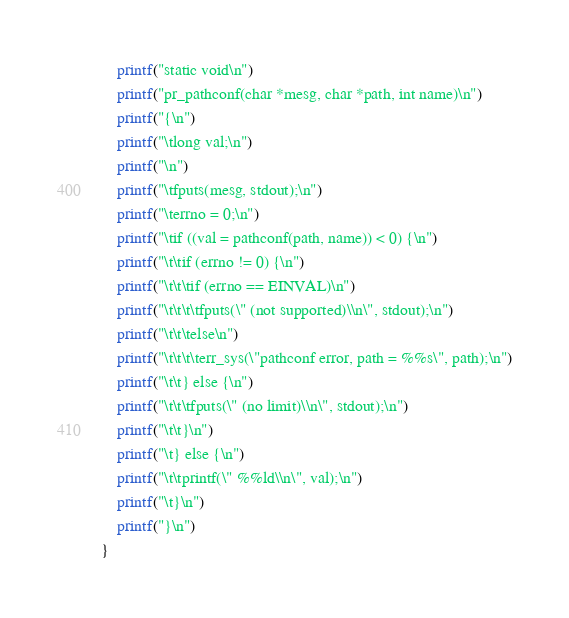<code> <loc_0><loc_0><loc_500><loc_500><_Awk_>	printf("static void\n")
	printf("pr_pathconf(char *mesg, char *path, int name)\n")
	printf("{\n")
	printf("\tlong	val;\n")
	printf("\n")
	printf("\tfputs(mesg, stdout);\n")
	printf("\terrno = 0;\n")
	printf("\tif ((val = pathconf(path, name)) < 0) {\n")
	printf("\t\tif (errno != 0) {\n")
	printf("\t\t\tif (errno == EINVAL)\n")
	printf("\t\t\t\tfputs(\" (not supported)\\n\", stdout);\n")
	printf("\t\t\telse\n")
	printf("\t\t\t\terr_sys(\"pathconf error, path = %%s\", path);\n")
	printf("\t\t} else {\n")
	printf("\t\t\tfputs(\" (no limit)\\n\", stdout);\n")
	printf("\t\t}\n")
	printf("\t} else {\n")
	printf("\t\tprintf(\" %%ld\\n\", val);\n")
	printf("\t}\n")
	printf("}\n")
}</code> 